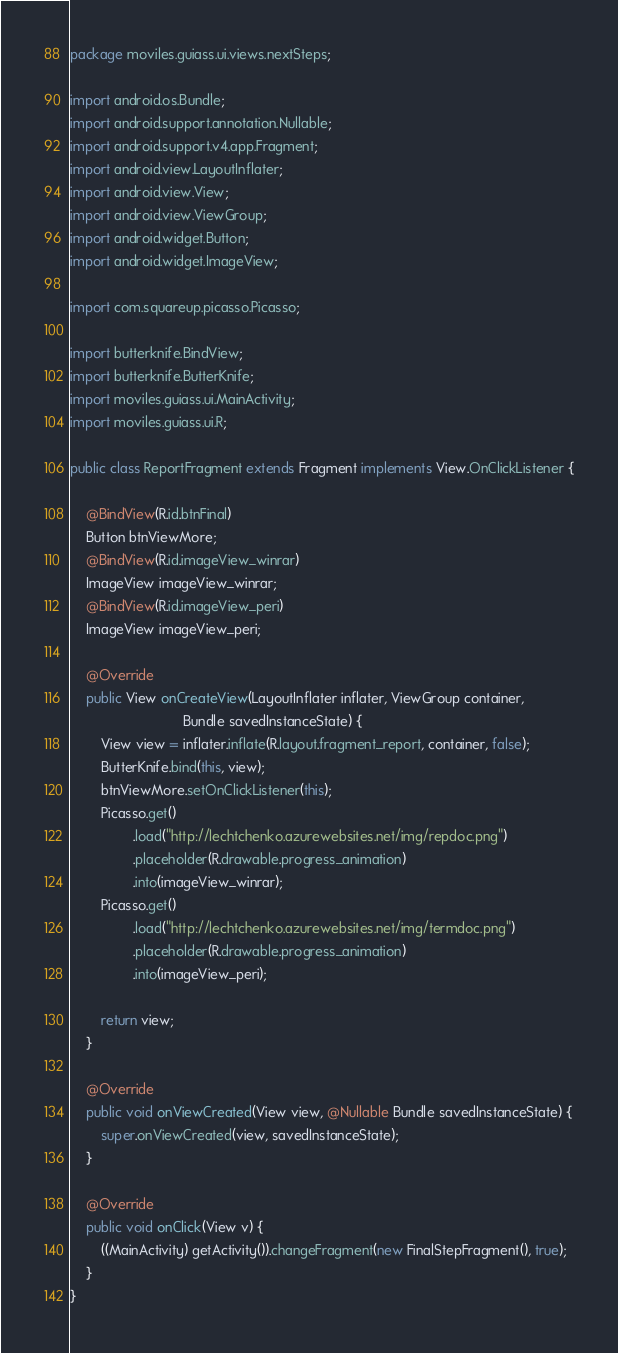<code> <loc_0><loc_0><loc_500><loc_500><_Java_>package moviles.guiass.ui.views.nextSteps;

import android.os.Bundle;
import android.support.annotation.Nullable;
import android.support.v4.app.Fragment;
import android.view.LayoutInflater;
import android.view.View;
import android.view.ViewGroup;
import android.widget.Button;
import android.widget.ImageView;

import com.squareup.picasso.Picasso;

import butterknife.BindView;
import butterknife.ButterKnife;
import moviles.guiass.ui.MainActivity;
import moviles.guiass.ui.R;

public class ReportFragment extends Fragment implements View.OnClickListener {

    @BindView(R.id.btnFinal)
    Button btnViewMore;
    @BindView(R.id.imageView_winrar)
    ImageView imageView_winrar;
    @BindView(R.id.imageView_peri)
    ImageView imageView_peri;

    @Override
    public View onCreateView(LayoutInflater inflater, ViewGroup container,
                             Bundle savedInstanceState) {
        View view = inflater.inflate(R.layout.fragment_report, container, false);
        ButterKnife.bind(this, view);
        btnViewMore.setOnClickListener(this);
        Picasso.get()
                .load("http://lechtchenko.azurewebsites.net/img/repdoc.png")
                .placeholder(R.drawable.progress_animation)
                .into(imageView_winrar);
        Picasso.get()
                .load("http://lechtchenko.azurewebsites.net/img/termdoc.png")
                .placeholder(R.drawable.progress_animation)
                .into(imageView_peri);

        return view;
    }

    @Override
    public void onViewCreated(View view, @Nullable Bundle savedInstanceState) {
        super.onViewCreated(view, savedInstanceState);
    }

    @Override
    public void onClick(View v) {
        ((MainActivity) getActivity()).changeFragment(new FinalStepFragment(), true);
    }
}
</code> 